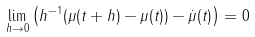Convert formula to latex. <formula><loc_0><loc_0><loc_500><loc_500>\lim _ { h \to 0 } \left ( h ^ { - 1 } ( \mu ( t + h ) - \mu ( t ) ) - \dot { \mu } ( t ) \right ) = 0</formula> 